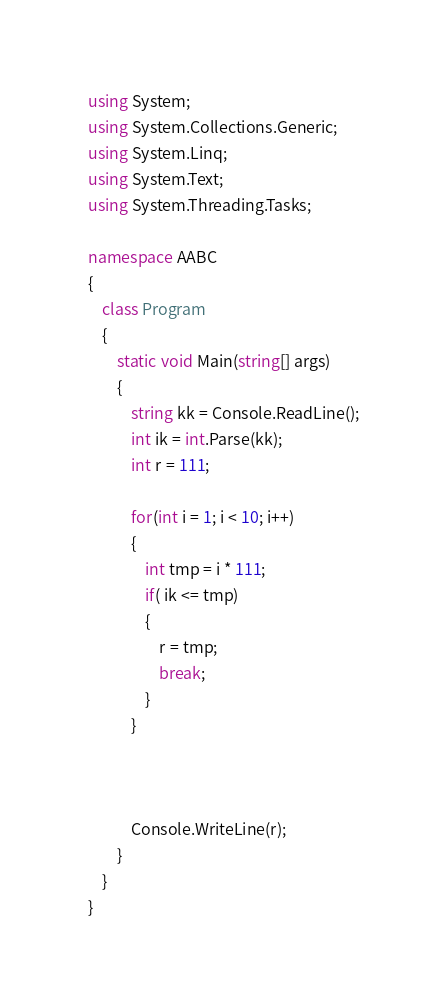<code> <loc_0><loc_0><loc_500><loc_500><_C#_>using System;
using System.Collections.Generic;
using System.Linq;
using System.Text;
using System.Threading.Tasks;

namespace AABC
{
    class Program
    {
        static void Main(string[] args)
        {
            string kk = Console.ReadLine();
            int ik = int.Parse(kk);
            int r = 111;

            for(int i = 1; i < 10; i++)
            {
                int tmp = i * 111;
                if( ik <= tmp)
                {
                    r = tmp;
                    break;
                }
            }

            

            Console.WriteLine(r);
        }
    }
}
</code> 